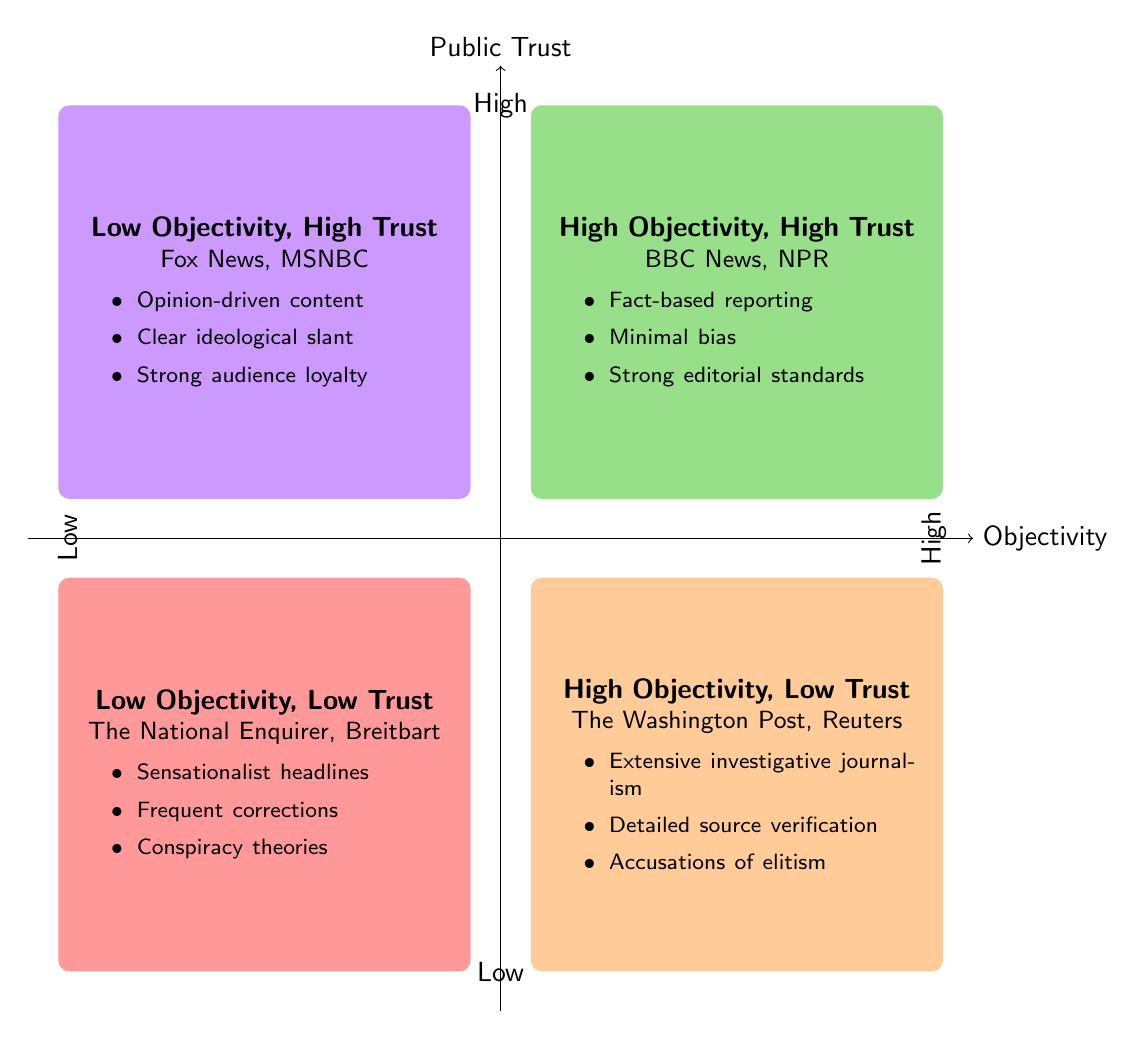What are the examples in the "High Objectivity, High Public Trust" quadrant? The quadrant labeled "High Objectivity, High Public Trust" contains the examples BBC News and NPR.
Answer: BBC News, NPR Which quadrant contains Fox News? Fox News is located in the quadrant titled "Low Objectivity, High Trust."
Answer: Low Objectivity, High Trust How many quadrants are shown in the diagram? The diagram displays a total of four quadrants, each representing different combinations of objectivity and public trust.
Answer: Four What characterizes the "Low Objectivity, Low Trust" quadrant? This quadrant is characterized by sensationalist headlines, frequent corrections, and conspiracy theories, which describe the nature of the content in this category.
Answer: Sensationalist headlines, frequent corrections, conspiracy theories Which quadrant is associated with high objectivity but low public trust? The quadrant titled "High Objectivity, Low Trust" is associated with this characteristic, which includes outlets like The Washington Post and Reuters.
Answer: High Objectivity, Low Trust What is the ideological slant in the "Low Objectivity, High Trust" quadrant? The ideological slant in the "Low Objectivity, High Trust" quadrant is characterized by opinion-driven content and a clear ideological stance, as represented by Fox News and MSNBC.
Answer: Clear ideological slant Which outlets are noted for having extensive investigative journalism? The outlets noted for having extensive investigative journalism are located in the "High Objectivity, Low Trust" quadrant, specifically The Washington Post and Reuters.
Answer: The Washington Post, Reuters What does the "High Objectivity, High Public Trust" quadrant imply about its examples? This quadrant implies that the examples therein, such as BBC News and NPR, maintain high standards of fact-based reporting and minimal bias, along with strong editorial standards.
Answer: Fact-based reporting, minimal bias, strong editorial standards 